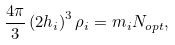Convert formula to latex. <formula><loc_0><loc_0><loc_500><loc_500>\frac { 4 \pi } { 3 } \left ( 2 h _ { i } \right ) ^ { 3 } \rho _ { i } = m _ { i } N _ { o p t } ,</formula> 